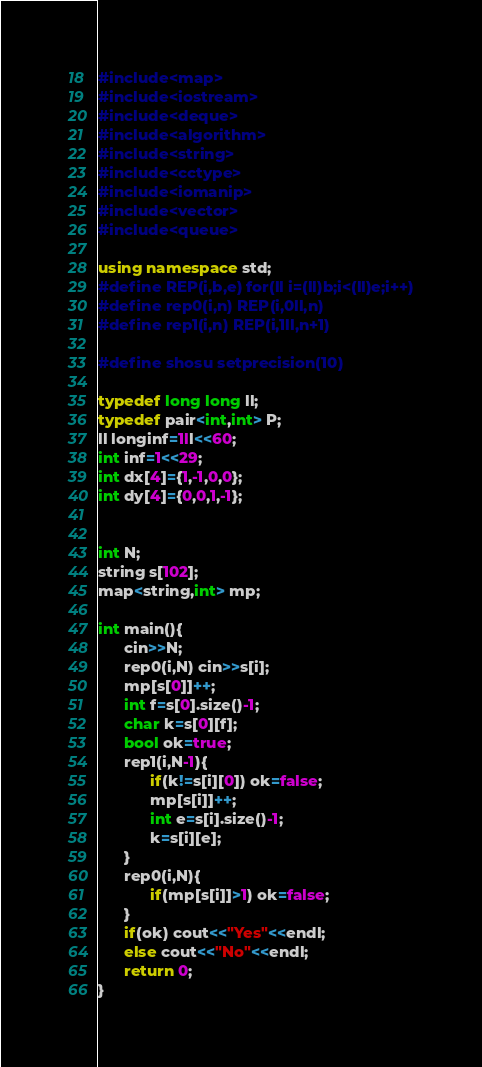Convert code to text. <code><loc_0><loc_0><loc_500><loc_500><_C++_>#include<map>
#include<iostream>
#include<deque>
#include<algorithm>
#include<string>
#include<cctype>
#include<iomanip>
#include<vector>
#include<queue>
 
using namespace std;
#define REP(i,b,e) for(ll i=(ll)b;i<(ll)e;i++)
#define rep0(i,n) REP(i,0ll,n)
#define rep1(i,n) REP(i,1ll,n+1)
 
#define shosu setprecision(10)
 
typedef long long ll;
typedef pair<int,int> P;
ll longinf=1ll<<60;
int inf=1<<29;
int dx[4]={1,-1,0,0};
int dy[4]={0,0,1,-1};


int N;
string s[102];
map<string,int> mp;

int main(){
      cin>>N;
      rep0(i,N) cin>>s[i];
      mp[s[0]]++;
      int f=s[0].size()-1;
      char k=s[0][f];
      bool ok=true;
      rep1(i,N-1){
            if(k!=s[i][0]) ok=false; 
            mp[s[i]]++;
            int e=s[i].size()-1;
            k=s[i][e];
      }
      rep0(i,N){
            if(mp[s[i]]>1) ok=false;
      }
      if(ok) cout<<"Yes"<<endl;
      else cout<<"No"<<endl;
      return 0;
}</code> 